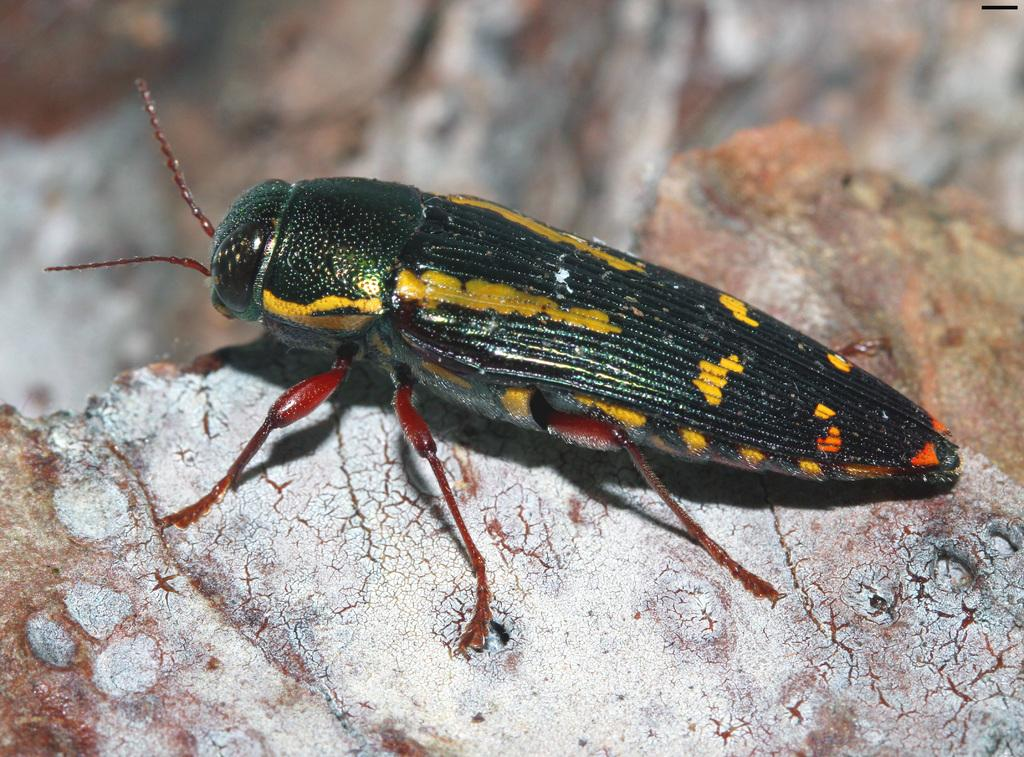What type of creature is present in the image? There is an insect in the picture. Can you describe the colors of the insect? The insect has green, yellow, and red colors. What type of plant is the insect using for digestion in the image? There is no plant present in the image, and the insect's digestion is not depicted. How does the insect's hair look in the image? Insects do not have hair, so this detail cannot be observed in the image. 